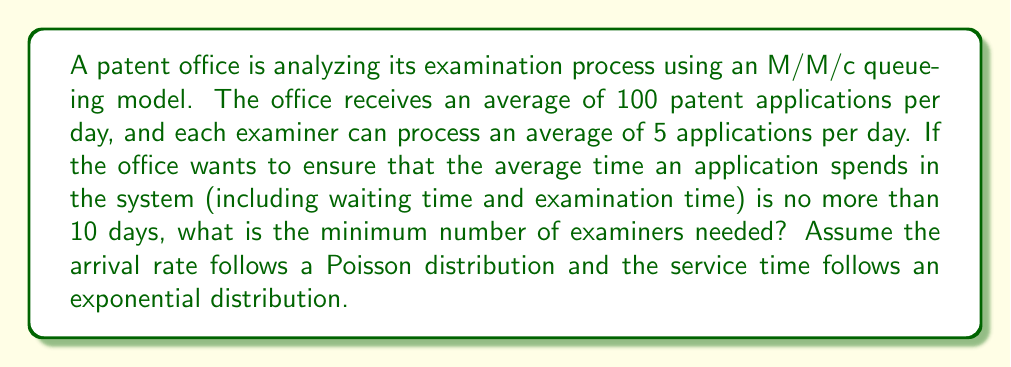What is the answer to this math problem? To solve this problem, we'll use the M/M/c queueing model, where:
- M: Markovian arrival process (Poisson distribution)
- M: Markovian service times (exponential distribution)
- c: Number of servers (examiners in this case)

Given:
- Arrival rate (λ) = 100 applications/day
- Service rate per examiner (μ) = 5 applications/day
- Target average time in system (W) ≤ 10 days

Step 1: Calculate the utilization factor ρ = λ/(cμ)
We need to find the minimum c such that ρ < 1 (for system stability) and W ≤ 10.

Step 2: Use the formula for average time in the system (W):
$$ W = \frac{1}{\mu} + \frac{P_0 (λ/μ)^c}{c!(1-ρ)^2} \cdot \frac{1}{cμ} $$

Where $P_0$ is the probability of an empty system:
$$ P_0 = \left[\sum_{n=0}^{c-1} \frac{1}{n!}\left(\frac{λ}{μ}\right)^n + \frac{1}{c!}\left(\frac{λ}{μ}\right)^c \cdot \frac{c\mu}{c\mu-λ}\right]^{-1} $$

Step 3: Start with the minimum number of examiners needed for system stability:
$c_{min} = \left\lceil\frac{λ}{μ}\right\rceil = \left\lceil\frac{100}{5}\right\rceil = 20$

Step 4: Iteratively increase c and calculate W until W ≤ 10:

For c = 20:
ρ = 100 / (20 * 5) = 1 (unstable system)

For c = 21:
ρ = 100 / (21 * 5) ≈ 0.9524
W ≈ 42.05 days (> 10 days)

Continue increasing c...

For c = 25:
ρ = 100 / (25 * 5) = 0.8
W ≈ 9.76 days (< 10 days)

Therefore, the minimum number of examiners needed is 25.
Answer: 25 examiners 